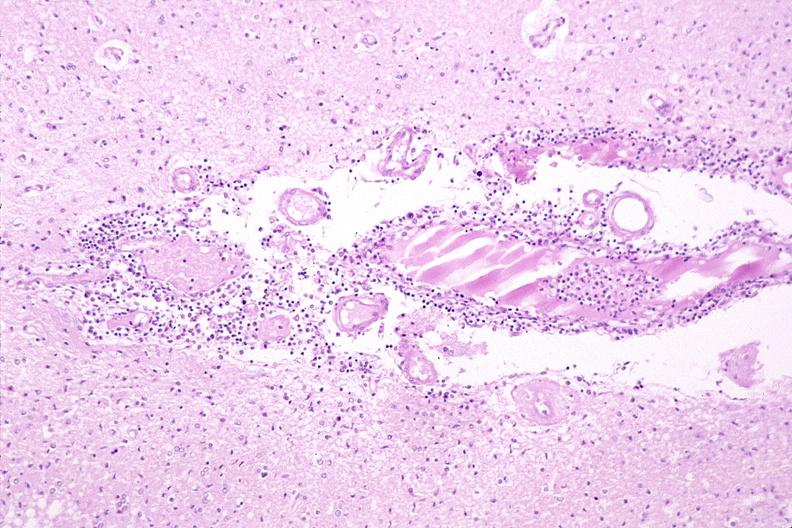s hemorrhage newborn present?
Answer the question using a single word or phrase. No 